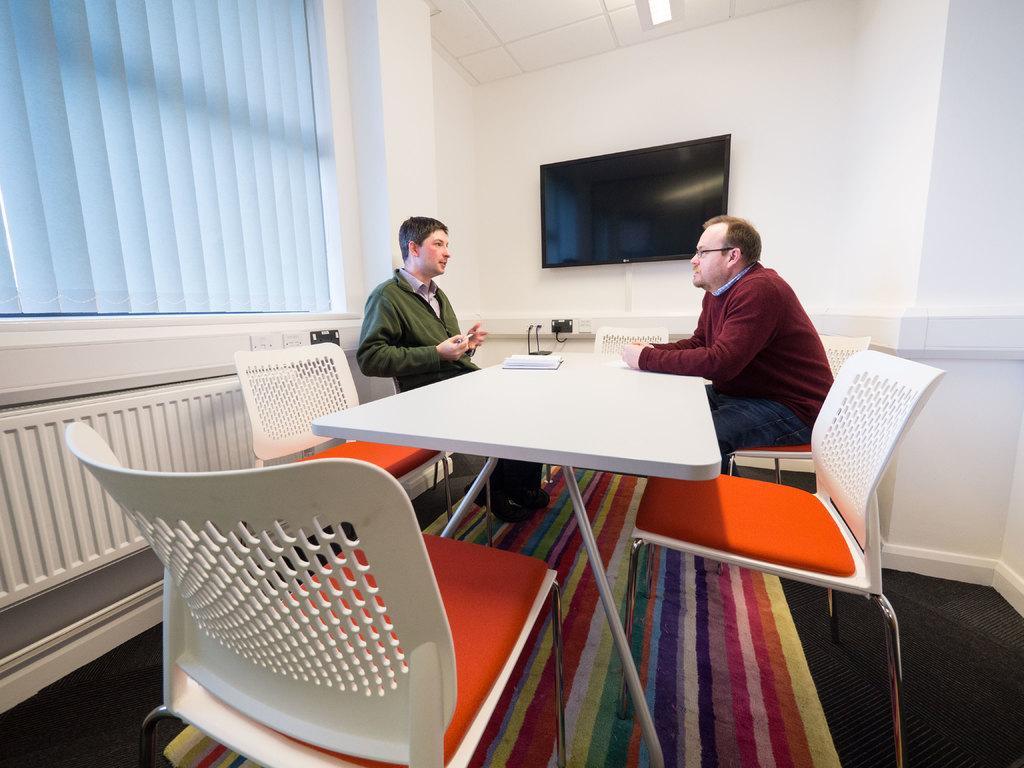How would you summarize this image in a sentence or two? The picture is inside a room, there is a white color table and there are some chairs around the table there are two persons sitting opposite to each other, to their left side there is a television to the wall, in the background there is a window and white color wall. 